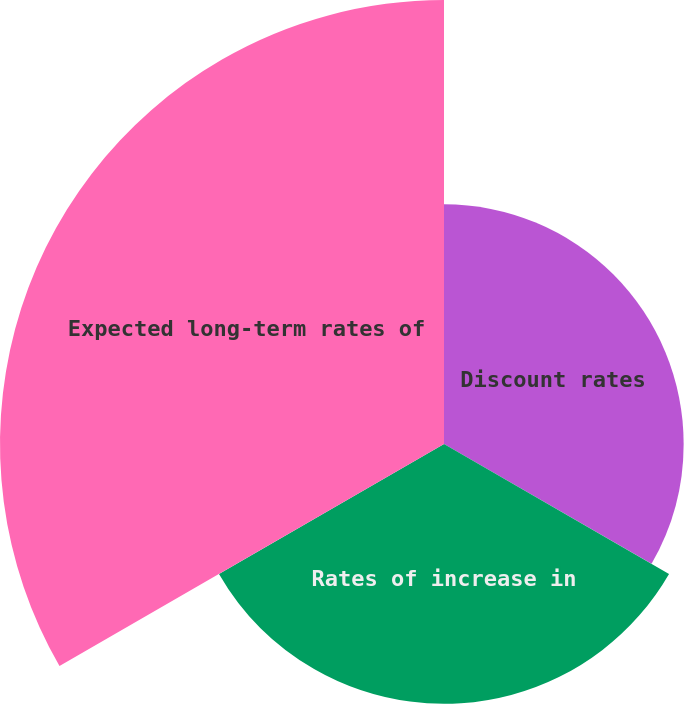Convert chart to OTSL. <chart><loc_0><loc_0><loc_500><loc_500><pie_chart><fcel>Discount rates<fcel>Rates of increase in<fcel>Expected long-term rates of<nl><fcel>25.4%<fcel>27.54%<fcel>47.06%<nl></chart> 